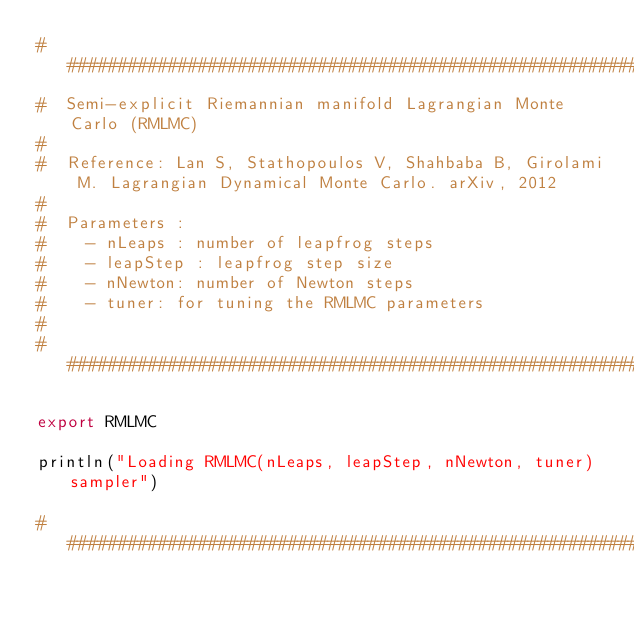Convert code to text. <code><loc_0><loc_0><loc_500><loc_500><_Julia_>###########################################################################
#  Semi-explicit Riemannian manifold Lagrangian Monte Carlo (RMLMC)
#
#  Reference: Lan S, Stathopoulos V, Shahbaba B, Girolami M. Lagrangian Dynamical Monte Carlo. arXiv, 2012
#
#  Parameters :
#    - nLeaps : number of leapfrog steps
#    - leapStep : leapfrog step size
#    - nNewton: number of Newton steps
#    - tuner: for tuning the RMLMC parameters
#
###########################################################################

export RMLMC

println("Loading RMLMC(nLeaps, leapStep, nNewton, tuner) sampler")

###########################################################################</code> 